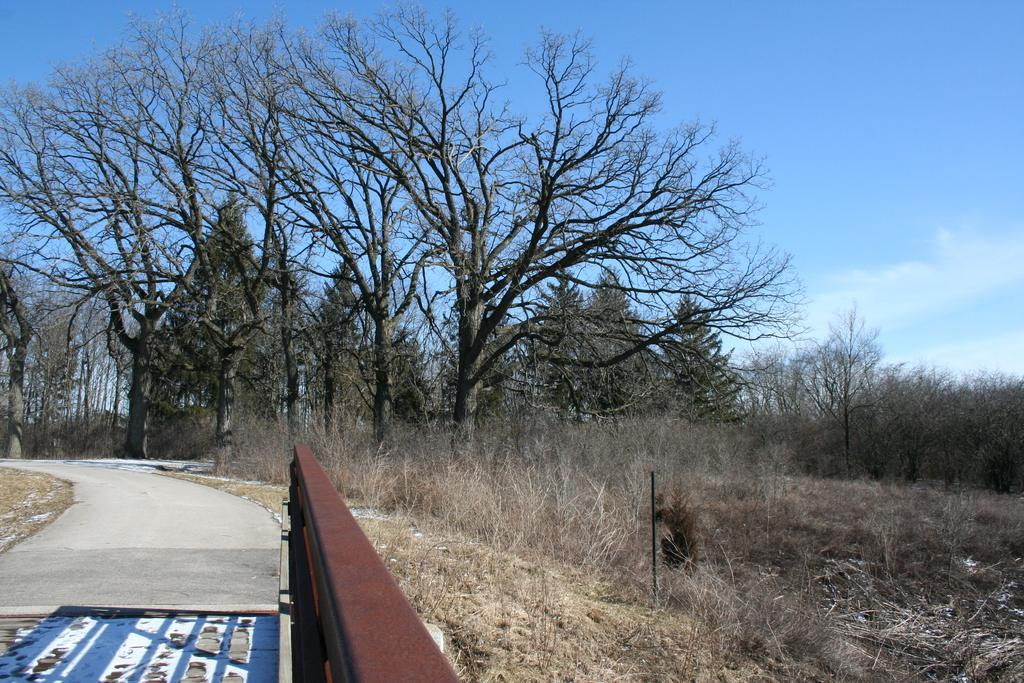What is located on the left side of the image? There is a road and an iron object on the left side of the image. What type of vegetation can be seen on the left side of the image? There is grass on the left side of the image. What is the condition of the grass on the right side of the image? There is dry grass on the right side of the image. What can be seen in the middle of the image? There are trees in the middle of the image. What is visible at the top of the image? The sky is visible at the top of the image. What type of canvas is being used to paint the trees in the image? There is no canvas or painting activity present in the image; it is a photograph of a real scene. Is there a prison visible in the image? There is no prison present in the image. 